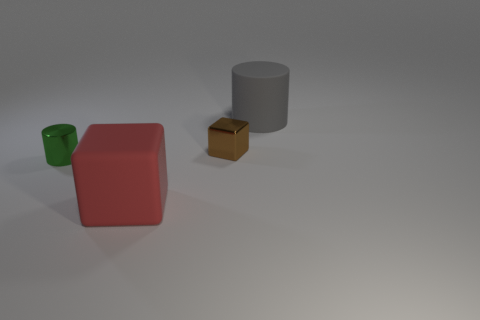Add 2 large gray matte cylinders. How many objects exist? 6 Add 1 green things. How many green things exist? 2 Subtract 1 red cubes. How many objects are left? 3 Subtract all red cubes. Subtract all green cylinders. How many objects are left? 2 Add 1 tiny green cylinders. How many tiny green cylinders are left? 2 